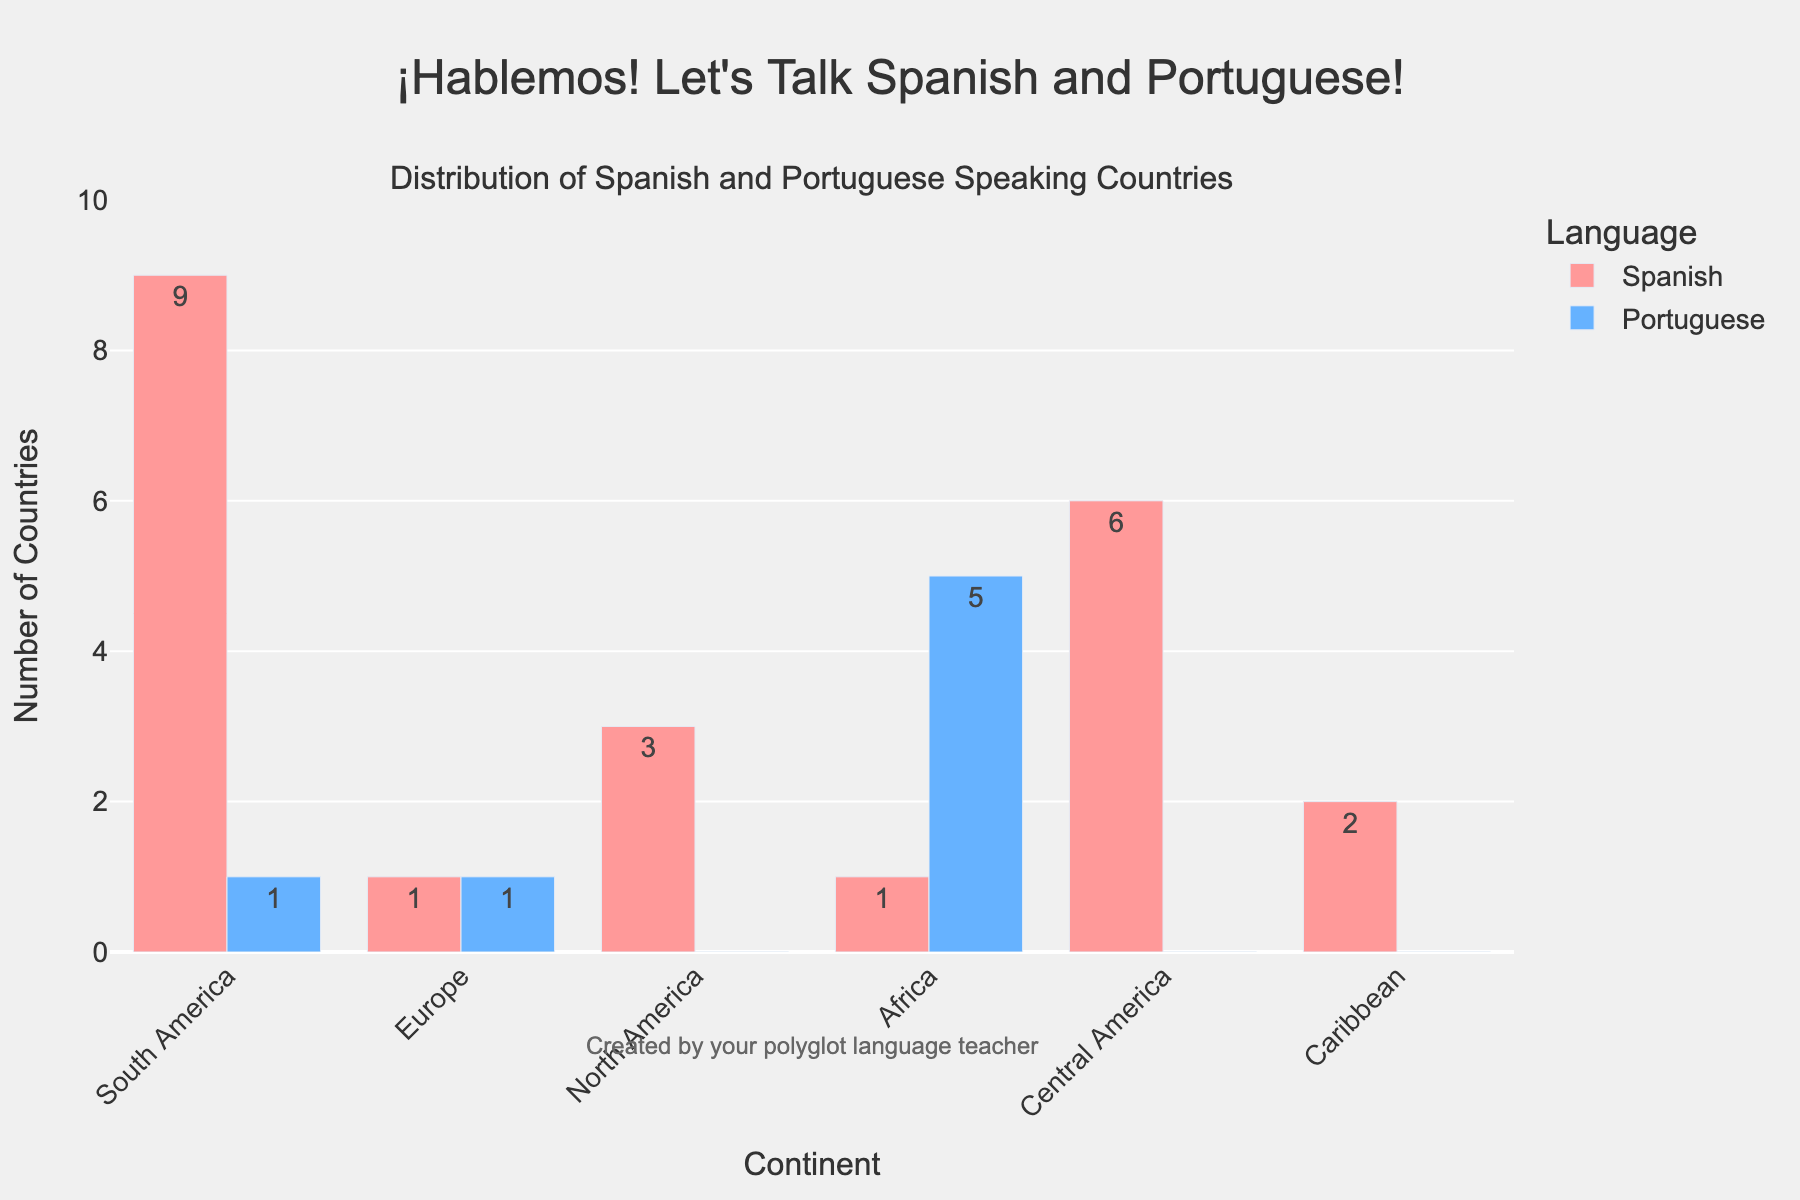Which continent has the most Spanish-speaking countries? The highest bar for Spanish-speaking countries is in South America with a value of 9.
Answer: South America What is the total number of Portuguese-speaking countries in Africa and Europe combined? The bar for Portuguese-speaking countries shows a value of 5 in Africa and 1 in Europe. Adding these gives 5 + 1 = 6.
Answer: 6 Which continent has the highest number of Portuguese-speaking countries? The tallest bar for Portuguese-speaking countries is Africa which shows a value of 5.
Answer: Africa How many more Spanish-speaking countries are there in South America compared to Central America? The bar for Spanish-speaking countries in South America is 9, and in Central America, it is 6. The difference is 9 - 6 = 3.
Answer: 3 What is the total number of Spanish-speaking countries across all continents? The number of Spanish-speaking countries by continent are: 9 (South America), 1 (Europe), 3 (North America), 1 (Africa), 6 (Central America), and 2 (Caribbean). Adding these gives 9 + 1 + 3 + 1 + 6 + 2 = 22.
Answer: 22 Which continent has Spanish-speaking countries but no Portuguese-speaking countries? North America, Central America, and the Caribbean have values for Spanish-speaking countries and 0 for Portuguese-speaking countries.
Answer: North America, Central America, Caribbean Which continent has both Spanish-speaking and Portuguese-speaking countries, and how many of each? The bars for Europe and Africa show values for both Spanish-speaking and Portuguese-speaking countries. Europe has 1 Spanish and 1 Portuguese-speaking country, while Africa has 1 Spanish and 5 Portuguese-speaking countries.
Answer: Europe: 1 Spanish, 1 Portuguese; Africa: 1 Spanish, 5 Portuguese What is the difference between the number of Spanish-speaking and Portuguese-speaking countries in South America? South America has 9 Spanish-speaking countries and 1 Portuguese-speaking country. The difference is 9 - 1 = 8.
Answer: 8 Which language is spoken in the highest number of countries in Central America? The bar for Spanish-speaking countries in Central America is 6, whereas for Portuguese-speaking countries, it is 0. Therefore, Spanish is spoken in more countries.
Answer: Spanish How many continents have only one Spanish-speaking country? The bars show that Europe and Africa each have 1 Spanish-speaking country.
Answer: 2 